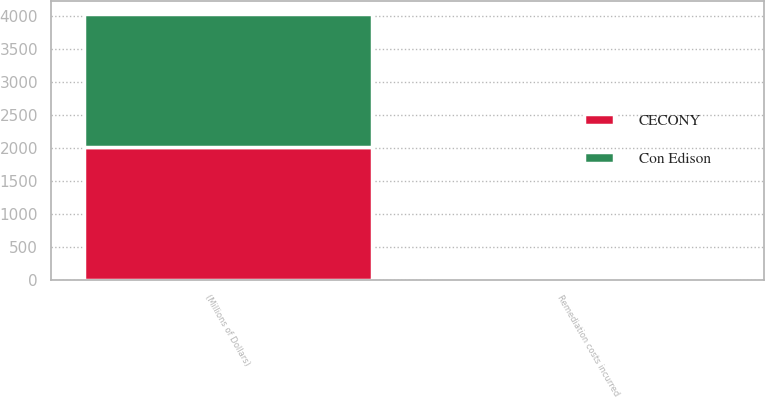<chart> <loc_0><loc_0><loc_500><loc_500><stacked_bar_chart><ecel><fcel>(Millions of Dollars)<fcel>Remediation costs incurred<nl><fcel>CECONY<fcel>2018<fcel>25<nl><fcel>Con Edison<fcel>2018<fcel>18<nl></chart> 